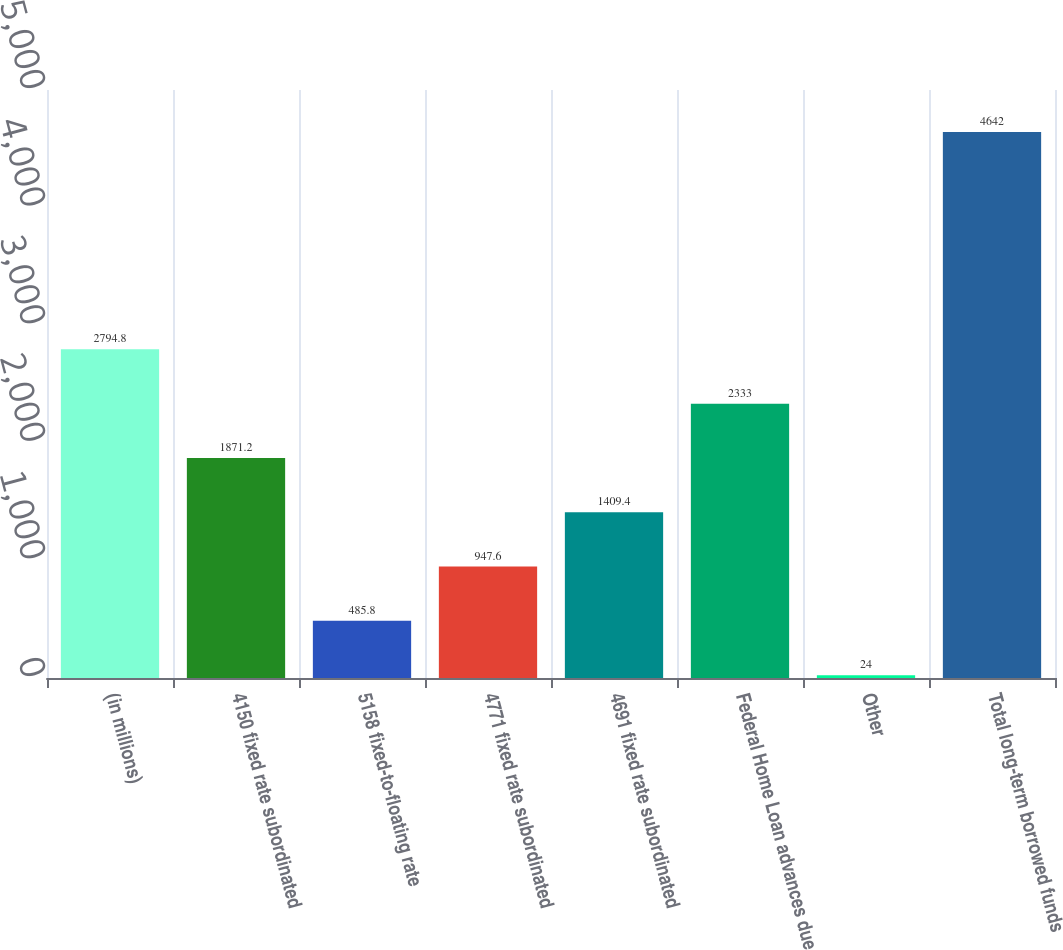Convert chart to OTSL. <chart><loc_0><loc_0><loc_500><loc_500><bar_chart><fcel>(in millions)<fcel>4150 fixed rate subordinated<fcel>5158 fixed-to-floating rate<fcel>4771 fixed rate subordinated<fcel>4691 fixed rate subordinated<fcel>Federal Home Loan advances due<fcel>Other<fcel>Total long-term borrowed funds<nl><fcel>2794.8<fcel>1871.2<fcel>485.8<fcel>947.6<fcel>1409.4<fcel>2333<fcel>24<fcel>4642<nl></chart> 